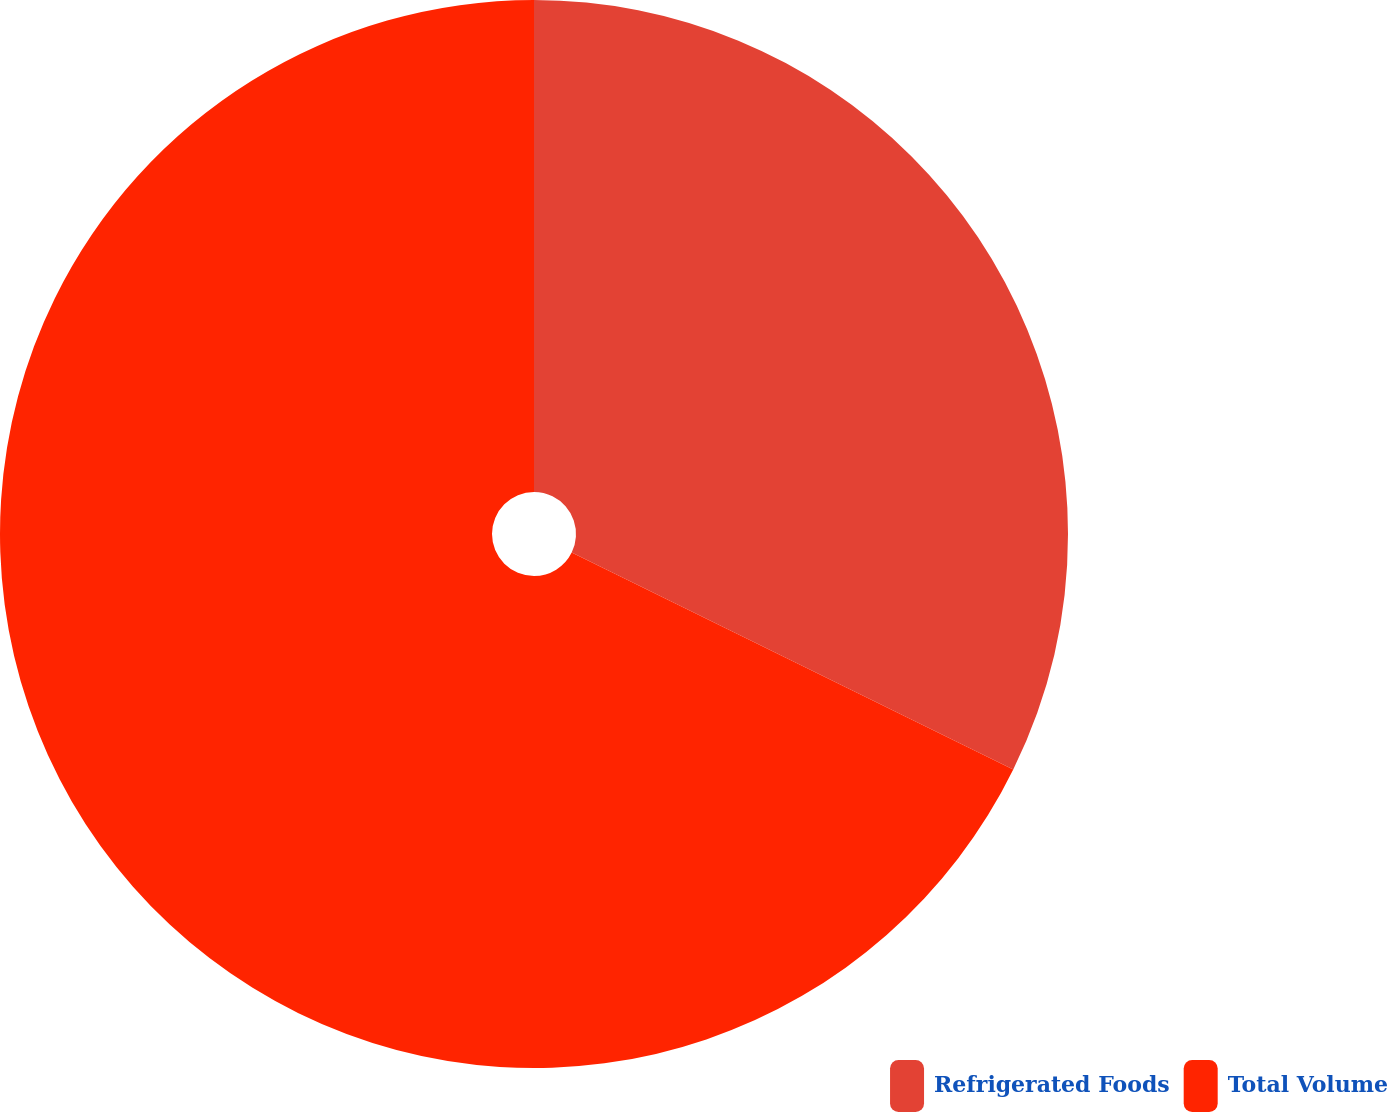Convert chart. <chart><loc_0><loc_0><loc_500><loc_500><pie_chart><fcel>Refrigerated Foods<fcel>Total Volume<nl><fcel>32.27%<fcel>67.73%<nl></chart> 